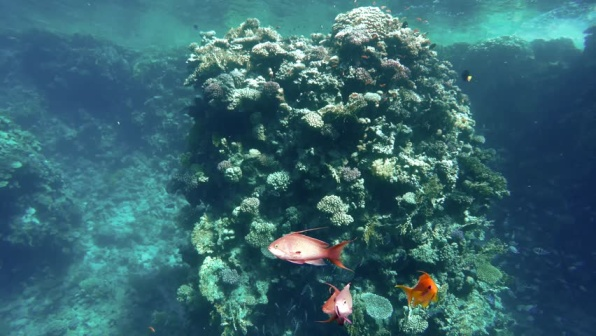Analyze the image in a comprehensive and detailed manner. The image presents a breathtaking underwater scene centered around a flourishing coral reef. At the heart of the composition is a towering mound of coral, teeming with a plethora of species such as brain coral, staghorn coral, and more. These corals exhibit an impressive array of colors, ranging from vibrant greens and rich browns to fiery oranges. This striking palette contrasts with the deep blue-green hues of the surrounding water, creating a vivid and mesmerizing landscape.

Adding to the dynamic nature of the scene are three fish, adorned with shades of pink, orange, and yellow, swimming gracefully in a counter-clockwise pattern around the coral. Their presence injects life and motion into the otherwise tranquil setting.

The photograph is bathed in natural sunlight filtering through the water from the top left corner, indicating that it was likely shot near the ocean's surface. This gentle illumination adds depth and dimension to the scene, enhancing the visibility of the intricate details.

Overall, the image captures the essence of the coral reef's rich biodiversity and intricate ecosystem. Every element, from the smallest coral polyp to the vividly colored fish, plays a crucial role in this underwater paradise, highlighting the unparalleled beauty and complexity of marine life. 